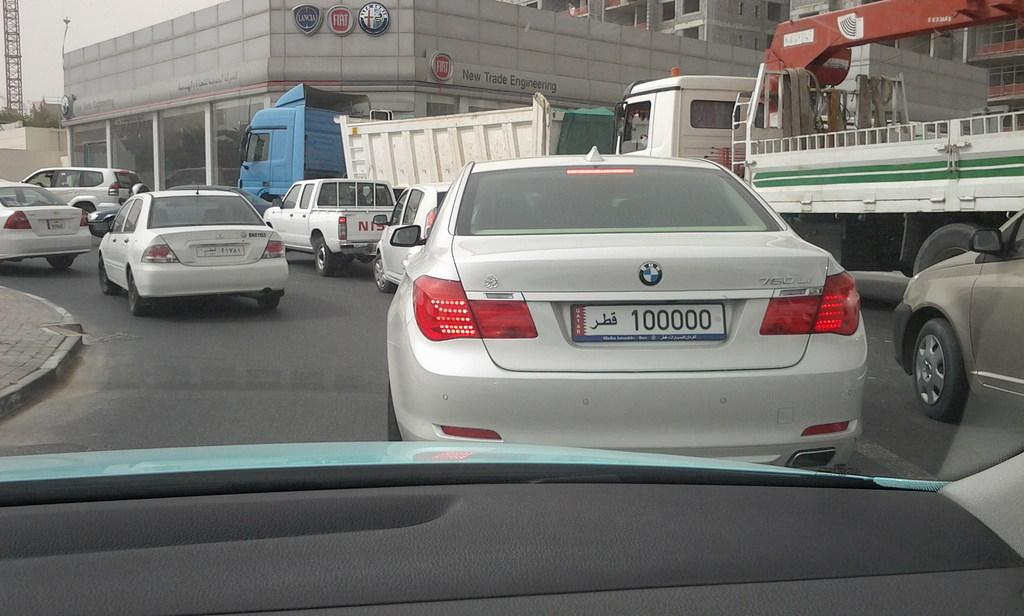<image>
Offer a succinct explanation of the picture presented. A white BMW with the number plate 100000 waits in busy traffic. 